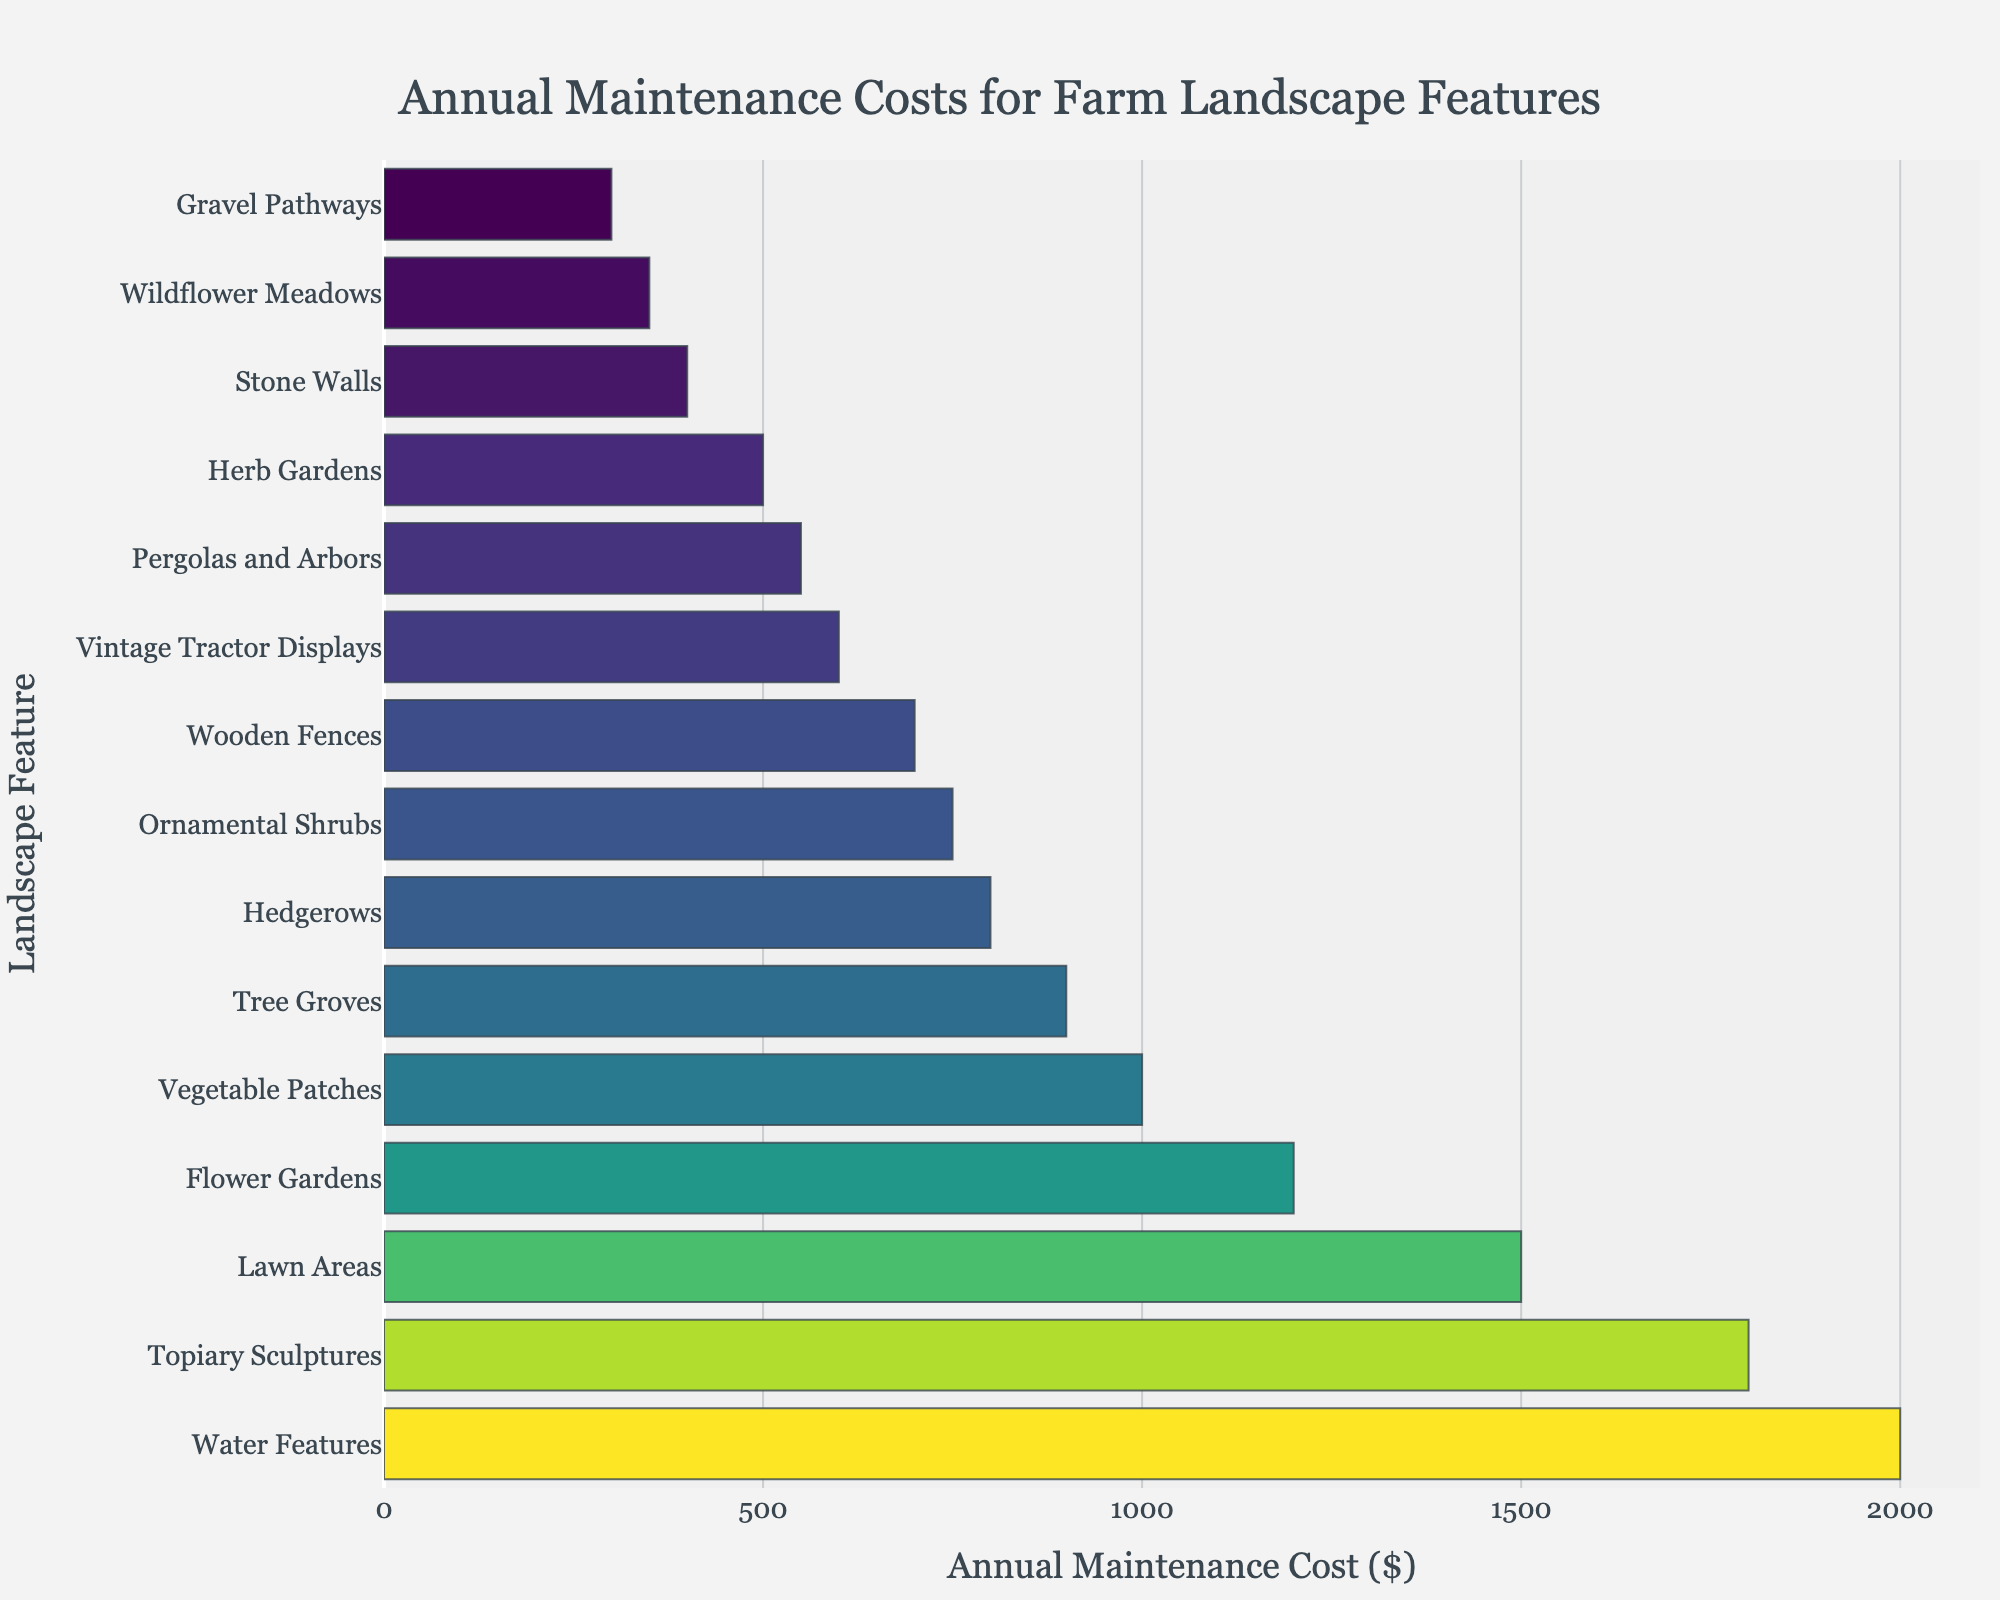What are the top three most expensive farm landscape features to maintain annually? Refer to the bar chart and identify the three features with the longest bars indicating the highest costs. These should be at the top of the sorted list. The top three features are Water Features, Topiary Sculptures, and Lawn Areas.
Answer: Water Features, Topiary Sculptures, Lawn Areas How much more does it cost to maintain Lawn Areas compared to Vintage Tractor Displays annually? Locate the annual maintenance costs for both Lawn Areas ($1500) and Vintage Tractor Displays ($600) in the bar chart. Subtract the cost for Vintage Tractor Displays from the cost for Lawn Areas: $1500 - $600.
Answer: $900 Which landscape feature has a maintenance cost closest to $1000 annually? Look for the bar in the bar chart that is closest to the $1000 mark. The feature with the maintenance cost closest to $1000 is Vegetable Patches, which costs $1000 annually.
Answer: Vegetable Patches What is the combined annual maintenance cost for Flower Gardens and Herb Gardens? Locate the annual maintenance costs for Flower Gardens ($1200) and Herb Gardens ($500) in the bar chart. Add these values together: $1200 + $500.
Answer: $1700 Which two landscape features have the least difference in their maintenance costs, and what is the difference? Identify pairs of features with adjacent maintenance costs and find the pair with the smallest difference. Ornamental Shrubs ($750) and Hedgerows ($800) have the smallest difference in their costs. The difference is $800 - $750.
Answer: Ornamental Shrubs and Hedgerows, $50 Among the features with an annual maintenance cost less than $500, which one has the longest bar (highest cost)? Narrow down to features with costs below $500: Herb Gardens, Stone Walls, Gravel Pathways, Pergolas and Arbors, Wildflower Meadows. Find the one with the highest cost, which corresponds to the longest bar among these.
Answer: Herb Gardens How many landscape features have annual maintenance costs greater than $1000? Count the number of bars in the chart that exceed the $1000 mark. There are five bars/features with maintenance costs greater than $1000: Flower Gardens, Lawn Areas, Water Features, Topiary Sculptures, and Lawn Areas.
Answer: 5 